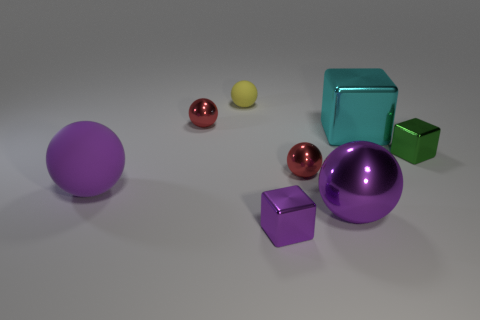Is there a large metal block that is on the left side of the red shiny object on the right side of the red metallic thing that is to the left of the tiny matte ball?
Provide a short and direct response. No. How many metal things are either red spheres or balls?
Offer a very short reply. 3. Do the small rubber sphere and the large metal sphere have the same color?
Your response must be concise. No. There is a large rubber sphere; how many small green objects are right of it?
Provide a succinct answer. 1. How many cubes are both on the right side of the large cyan object and in front of the green shiny block?
Provide a short and direct response. 0. What is the shape of the cyan object that is made of the same material as the green object?
Provide a succinct answer. Cube. Is the size of the matte ball behind the big rubber thing the same as the cube to the right of the cyan metallic cube?
Provide a short and direct response. Yes. There is a shiny cube in front of the large metal sphere; what color is it?
Provide a succinct answer. Purple. What material is the red object that is on the right side of the metal sphere behind the tiny green metallic object?
Ensure brevity in your answer.  Metal. The tiny matte object has what shape?
Your response must be concise. Sphere. 